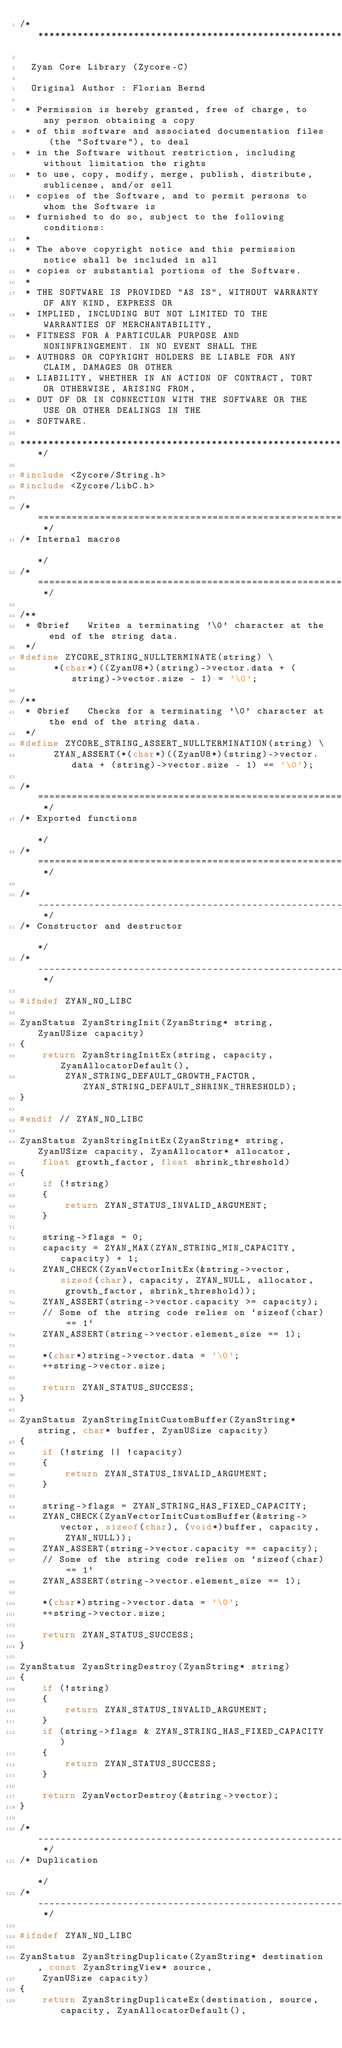Convert code to text. <code><loc_0><loc_0><loc_500><loc_500><_C_>/***************************************************************************************************

  Zyan Core Library (Zycore-C)

  Original Author : Florian Bernd

 * Permission is hereby granted, free of charge, to any person obtaining a copy
 * of this software and associated documentation files (the "Software"), to deal
 * in the Software without restriction, including without limitation the rights
 * to use, copy, modify, merge, publish, distribute, sublicense, and/or sell
 * copies of the Software, and to permit persons to whom the Software is
 * furnished to do so, subject to the following conditions:
 *
 * The above copyright notice and this permission notice shall be included in all
 * copies or substantial portions of the Software.
 *
 * THE SOFTWARE IS PROVIDED "AS IS", WITHOUT WARRANTY OF ANY KIND, EXPRESS OR
 * IMPLIED, INCLUDING BUT NOT LIMITED TO THE WARRANTIES OF MERCHANTABILITY,
 * FITNESS FOR A PARTICULAR PURPOSE AND NONINFRINGEMENT. IN NO EVENT SHALL THE
 * AUTHORS OR COPYRIGHT HOLDERS BE LIABLE FOR ANY CLAIM, DAMAGES OR OTHER
 * LIABILITY, WHETHER IN AN ACTION OF CONTRACT, TORT OR OTHERWISE, ARISING FROM,
 * OUT OF OR IN CONNECTION WITH THE SOFTWARE OR THE USE OR OTHER DEALINGS IN THE
 * SOFTWARE.

***************************************************************************************************/

#include <Zycore/String.h>
#include <Zycore/LibC.h>

/* ============================================================================================== */
/* Internal macros                                                                                */
/* ============================================================================================== */

/**
 * @brief   Writes a terminating '\0' character at the end of the string data.
 */
#define ZYCORE_STRING_NULLTERMINATE(string) \
      *(char*)((ZyanU8*)(string)->vector.data + (string)->vector.size - 1) = '\0';

/**
 * @brief   Checks for a terminating '\0' character at the end of the string data.
 */
#define ZYCORE_STRING_ASSERT_NULLTERMINATION(string) \
      ZYAN_ASSERT(*(char*)((ZyanU8*)(string)->vector.data + (string)->vector.size - 1) == '\0');

/* ============================================================================================== */
/* Exported functions                                                                             */
/* ============================================================================================== */

/* ---------------------------------------------------------------------------------------------- */
/* Constructor and destructor                                                                     */
/* ---------------------------------------------------------------------------------------------- */

#ifndef ZYAN_NO_LIBC

ZyanStatus ZyanStringInit(ZyanString* string, ZyanUSize capacity)
{
    return ZyanStringInitEx(string, capacity, ZyanAllocatorDefault(),
        ZYAN_STRING_DEFAULT_GROWTH_FACTOR, ZYAN_STRING_DEFAULT_SHRINK_THRESHOLD);
}

#endif // ZYAN_NO_LIBC

ZyanStatus ZyanStringInitEx(ZyanString* string, ZyanUSize capacity, ZyanAllocator* allocator,
    float growth_factor, float shrink_threshold)
{
    if (!string)
    {
        return ZYAN_STATUS_INVALID_ARGUMENT;
    }

    string->flags = 0;
    capacity = ZYAN_MAX(ZYAN_STRING_MIN_CAPACITY, capacity) + 1;
    ZYAN_CHECK(ZyanVectorInitEx(&string->vector, sizeof(char), capacity, ZYAN_NULL, allocator,
        growth_factor, shrink_threshold));
    ZYAN_ASSERT(string->vector.capacity >= capacity);
    // Some of the string code relies on `sizeof(char) == 1`
    ZYAN_ASSERT(string->vector.element_size == 1);

    *(char*)string->vector.data = '\0';
    ++string->vector.size;

    return ZYAN_STATUS_SUCCESS;
}

ZyanStatus ZyanStringInitCustomBuffer(ZyanString* string, char* buffer, ZyanUSize capacity)
{
    if (!string || !capacity)
    {
        return ZYAN_STATUS_INVALID_ARGUMENT;
    }

    string->flags = ZYAN_STRING_HAS_FIXED_CAPACITY;
    ZYAN_CHECK(ZyanVectorInitCustomBuffer(&string->vector, sizeof(char), (void*)buffer, capacity, 
        ZYAN_NULL));
    ZYAN_ASSERT(string->vector.capacity == capacity);
    // Some of the string code relies on `sizeof(char) == 1`
    ZYAN_ASSERT(string->vector.element_size == 1);

    *(char*)string->vector.data = '\0';
    ++string->vector.size;

    return ZYAN_STATUS_SUCCESS;
}

ZyanStatus ZyanStringDestroy(ZyanString* string)
{
    if (!string)
    {
        return ZYAN_STATUS_INVALID_ARGUMENT;
    }
    if (string->flags & ZYAN_STRING_HAS_FIXED_CAPACITY)
    {
        return ZYAN_STATUS_SUCCESS;
    }

    return ZyanVectorDestroy(&string->vector);
}

/* ---------------------------------------------------------------------------------------------- */
/* Duplication                                                                                    */
/* ---------------------------------------------------------------------------------------------- */

#ifndef ZYAN_NO_LIBC

ZyanStatus ZyanStringDuplicate(ZyanString* destination, const ZyanStringView* source,
    ZyanUSize capacity)
{
    return ZyanStringDuplicateEx(destination, source, capacity, ZyanAllocatorDefault(),</code> 